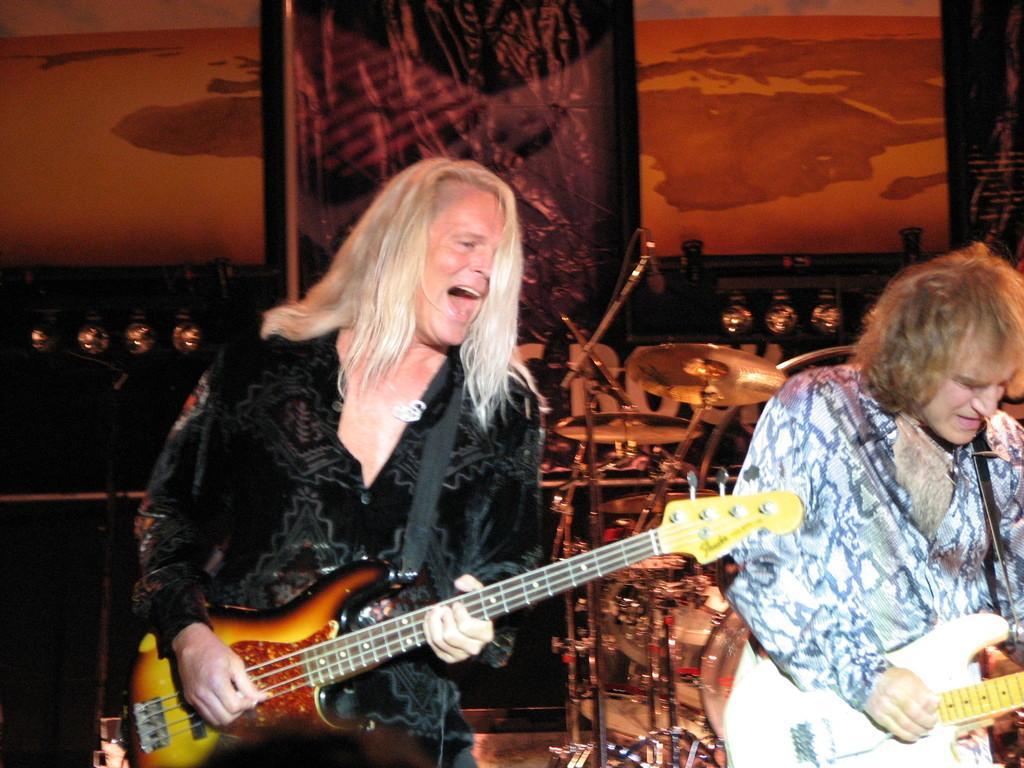Describe this image in one or two sentences. This man wore guitar and singing. Beside this person another person is also playing a guitar. Far these are musical instruments. 